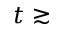<formula> <loc_0><loc_0><loc_500><loc_500>t \gtrsim</formula> 